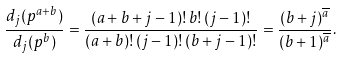<formula> <loc_0><loc_0><loc_500><loc_500>\frac { d _ { j } ( p ^ { a + b } ) } { d _ { j } ( p ^ { b } ) } & = \frac { ( a + b + j - 1 ) ! \, b ! \, ( j - 1 ) ! } { ( a + b ) ! \, ( j - 1 ) ! \, ( b + j - 1 ) ! } = \frac { ( b + j ) ^ { \overline { a } } } { ( b + 1 ) ^ { \overline { a } } } .</formula> 